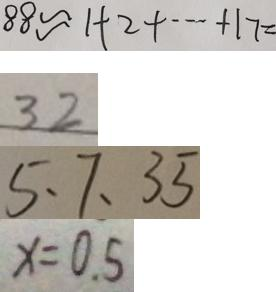Convert formula to latex. <formula><loc_0><loc_0><loc_500><loc_500>8 8 \approx 1 + 2 + \cdots + 1 7 = 
 3 2 
 5 、 7 、 3 5 
 x = 0 . 5</formula> 